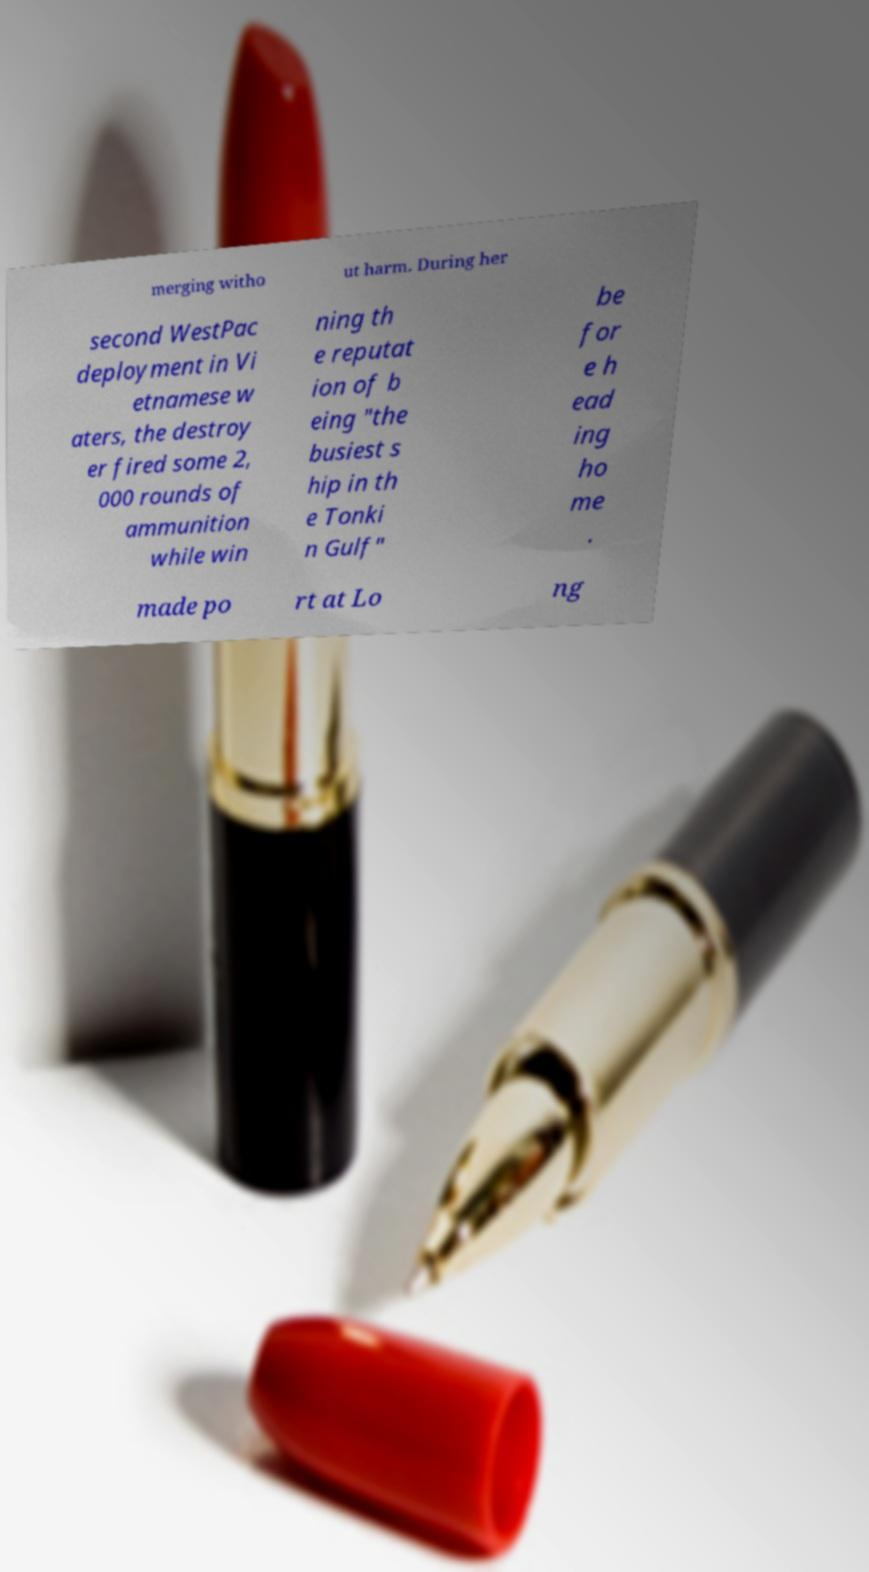I need the written content from this picture converted into text. Can you do that? merging witho ut harm. During her second WestPac deployment in Vi etnamese w aters, the destroy er fired some 2, 000 rounds of ammunition while win ning th e reputat ion of b eing "the busiest s hip in th e Tonki n Gulf" be for e h ead ing ho me . made po rt at Lo ng 